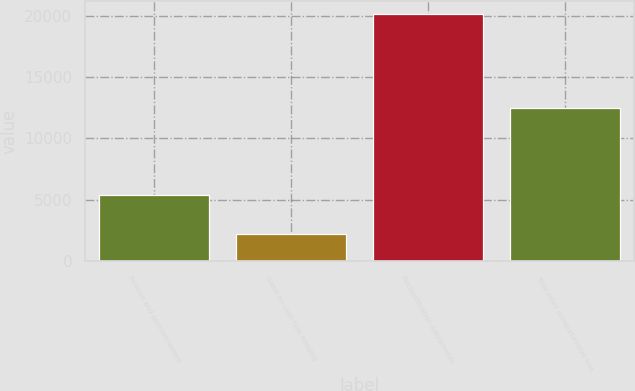Convert chart. <chart><loc_0><loc_0><loc_500><loc_500><bar_chart><fcel>Pension and post-retirement<fcel>Gains on cash flow hedging<fcel>Reclassification adjustments<fcel>Total other comprehensive loss<nl><fcel>5399<fcel>2259<fcel>20157<fcel>12499<nl></chart> 